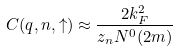<formula> <loc_0><loc_0><loc_500><loc_500>C ( { q } , n , \uparrow ) \approx \frac { 2 k ^ { 2 } _ { F } } { z _ { n } N ^ { 0 } ( 2 m ) }</formula> 